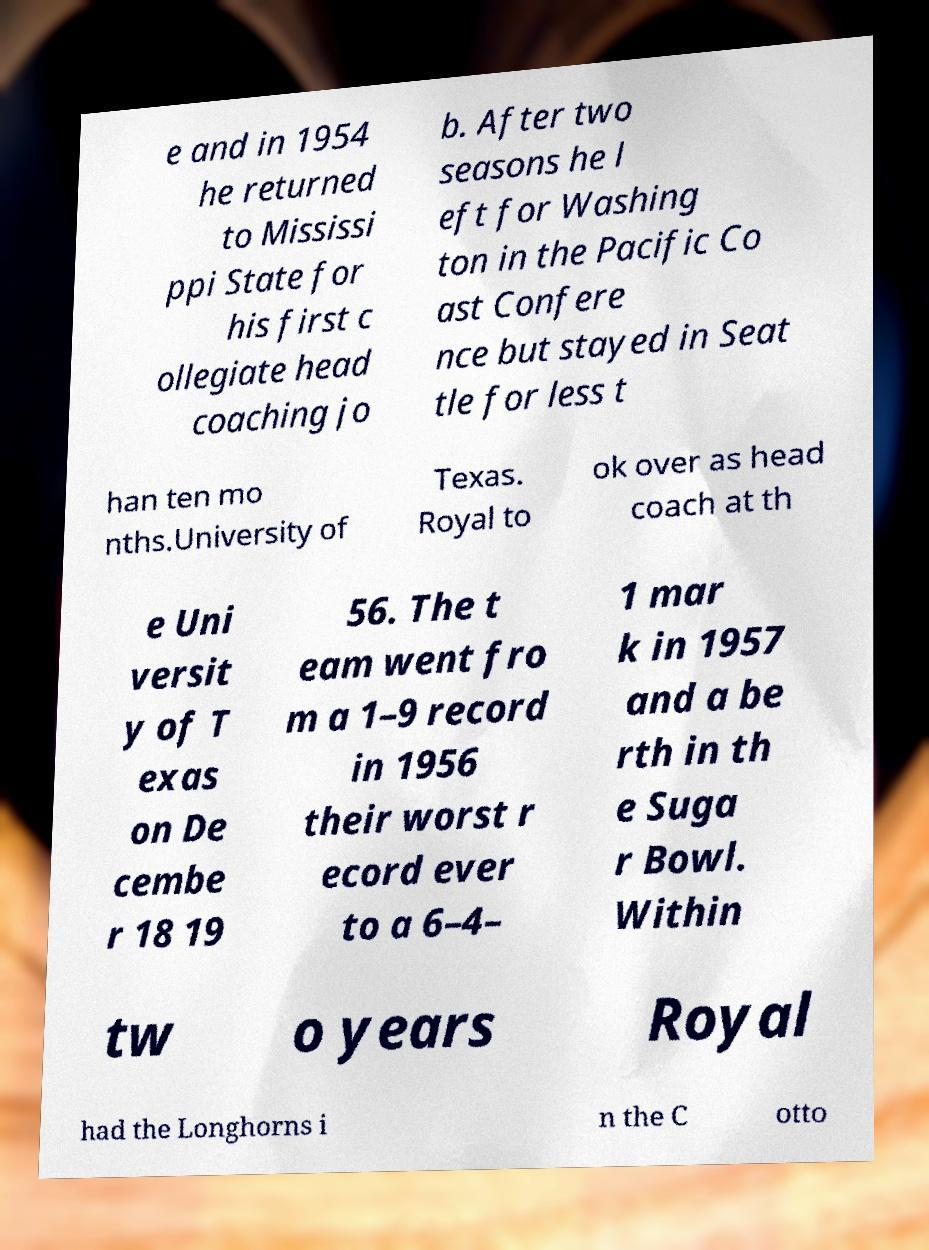Can you accurately transcribe the text from the provided image for me? e and in 1954 he returned to Mississi ppi State for his first c ollegiate head coaching jo b. After two seasons he l eft for Washing ton in the Pacific Co ast Confere nce but stayed in Seat tle for less t han ten mo nths.University of Texas. Royal to ok over as head coach at th e Uni versit y of T exas on De cembe r 18 19 56. The t eam went fro m a 1–9 record in 1956 their worst r ecord ever to a 6–4– 1 mar k in 1957 and a be rth in th e Suga r Bowl. Within tw o years Royal had the Longhorns i n the C otto 